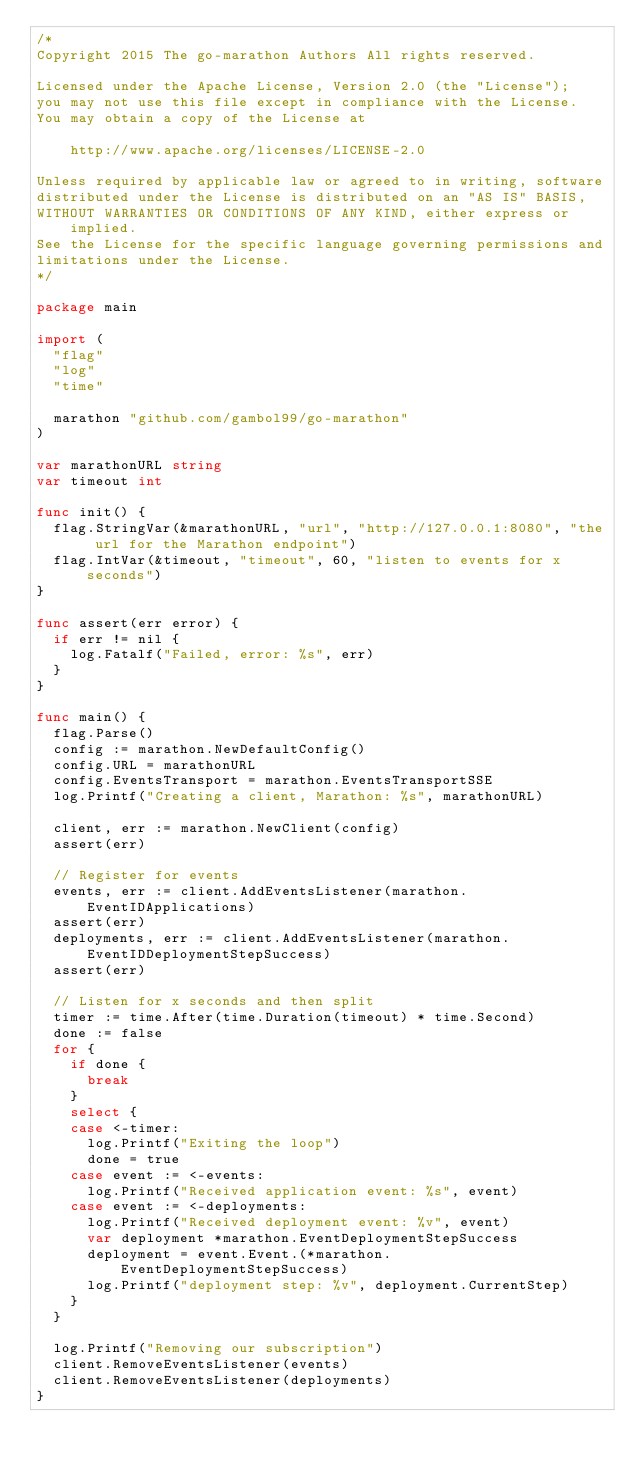<code> <loc_0><loc_0><loc_500><loc_500><_Go_>/*
Copyright 2015 The go-marathon Authors All rights reserved.

Licensed under the Apache License, Version 2.0 (the "License");
you may not use this file except in compliance with the License.
You may obtain a copy of the License at

    http://www.apache.org/licenses/LICENSE-2.0

Unless required by applicable law or agreed to in writing, software
distributed under the License is distributed on an "AS IS" BASIS,
WITHOUT WARRANTIES OR CONDITIONS OF ANY KIND, either express or implied.
See the License for the specific language governing permissions and
limitations under the License.
*/

package main

import (
	"flag"
	"log"
	"time"

	marathon "github.com/gambol99/go-marathon"
)

var marathonURL string
var timeout int

func init() {
	flag.StringVar(&marathonURL, "url", "http://127.0.0.1:8080", "the url for the Marathon endpoint")
	flag.IntVar(&timeout, "timeout", 60, "listen to events for x seconds")
}

func assert(err error) {
	if err != nil {
		log.Fatalf("Failed, error: %s", err)
	}
}

func main() {
	flag.Parse()
	config := marathon.NewDefaultConfig()
	config.URL = marathonURL
	config.EventsTransport = marathon.EventsTransportSSE
	log.Printf("Creating a client, Marathon: %s", marathonURL)

	client, err := marathon.NewClient(config)
	assert(err)

	// Register for events
	events, err := client.AddEventsListener(marathon.EventIDApplications)
	assert(err)
	deployments, err := client.AddEventsListener(marathon.EventIDDeploymentStepSuccess)
	assert(err)

	// Listen for x seconds and then split
	timer := time.After(time.Duration(timeout) * time.Second)
	done := false
	for {
		if done {
			break
		}
		select {
		case <-timer:
			log.Printf("Exiting the loop")
			done = true
		case event := <-events:
			log.Printf("Received application event: %s", event)
		case event := <-deployments:
			log.Printf("Received deployment event: %v", event)
			var deployment *marathon.EventDeploymentStepSuccess
			deployment = event.Event.(*marathon.EventDeploymentStepSuccess)
			log.Printf("deployment step: %v", deployment.CurrentStep)
		}
	}

	log.Printf("Removing our subscription")
	client.RemoveEventsListener(events)
	client.RemoveEventsListener(deployments)
}
</code> 